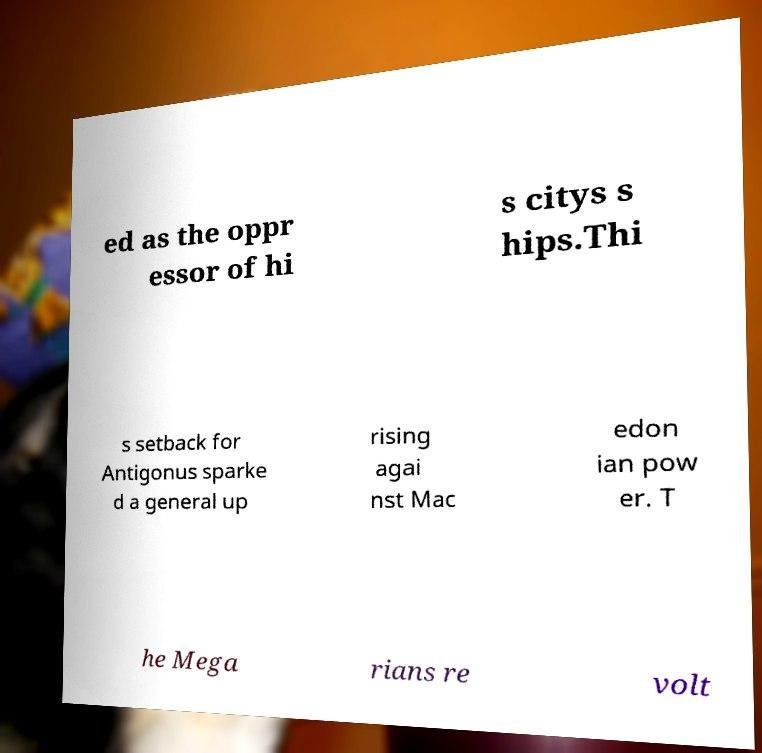Please identify and transcribe the text found in this image. ed as the oppr essor of hi s citys s hips.Thi s setback for Antigonus sparke d a general up rising agai nst Mac edon ian pow er. T he Mega rians re volt 